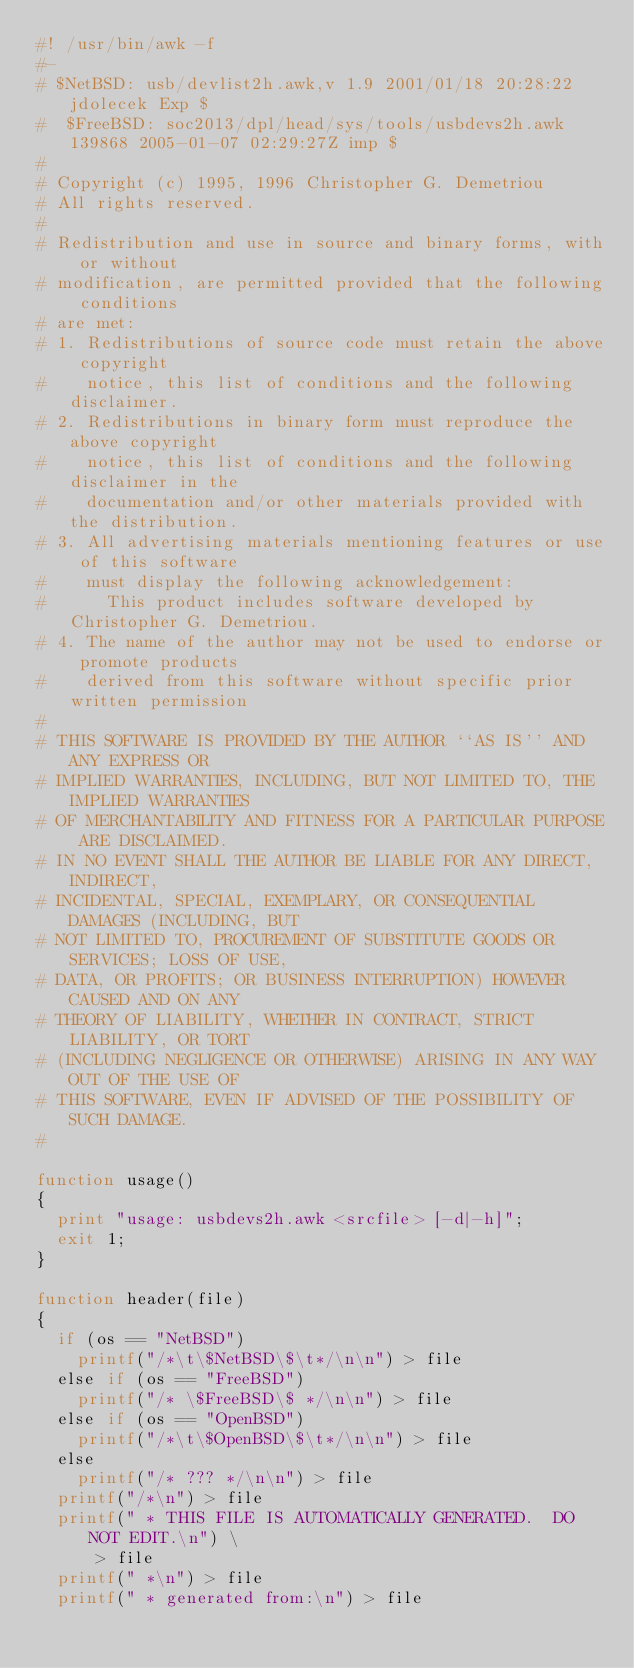Convert code to text. <code><loc_0><loc_0><loc_500><loc_500><_Awk_>#! /usr/bin/awk -f
#-
#	$NetBSD: usb/devlist2h.awk,v 1.9 2001/01/18 20:28:22 jdolecek Exp $
#  $FreeBSD: soc2013/dpl/head/sys/tools/usbdevs2h.awk 139868 2005-01-07 02:29:27Z imp $
#
# Copyright (c) 1995, 1996 Christopher G. Demetriou
# All rights reserved.
#
# Redistribution and use in source and binary forms, with or without
# modification, are permitted provided that the following conditions
# are met:
# 1. Redistributions of source code must retain the above copyright
#    notice, this list of conditions and the following disclaimer.
# 2. Redistributions in binary form must reproduce the above copyright
#    notice, this list of conditions and the following disclaimer in the
#    documentation and/or other materials provided with the distribution.
# 3. All advertising materials mentioning features or use of this software
#    must display the following acknowledgement:
#      This product includes software developed by Christopher G. Demetriou.
# 4. The name of the author may not be used to endorse or promote products
#    derived from this software without specific prior written permission
#
# THIS SOFTWARE IS PROVIDED BY THE AUTHOR ``AS IS'' AND ANY EXPRESS OR
# IMPLIED WARRANTIES, INCLUDING, BUT NOT LIMITED TO, THE IMPLIED WARRANTIES
# OF MERCHANTABILITY AND FITNESS FOR A PARTICULAR PURPOSE ARE DISCLAIMED.
# IN NO EVENT SHALL THE AUTHOR BE LIABLE FOR ANY DIRECT, INDIRECT,
# INCIDENTAL, SPECIAL, EXEMPLARY, OR CONSEQUENTIAL DAMAGES (INCLUDING, BUT
# NOT LIMITED TO, PROCUREMENT OF SUBSTITUTE GOODS OR SERVICES; LOSS OF USE,
# DATA, OR PROFITS; OR BUSINESS INTERRUPTION) HOWEVER CAUSED AND ON ANY
# THEORY OF LIABILITY, WHETHER IN CONTRACT, STRICT LIABILITY, OR TORT
# (INCLUDING NEGLIGENCE OR OTHERWISE) ARISING IN ANY WAY OUT OF THE USE OF
# THIS SOFTWARE, EVEN IF ADVISED OF THE POSSIBILITY OF SUCH DAMAGE.
#

function usage()
{
	print "usage: usbdevs2h.awk <srcfile> [-d|-h]";
	exit 1;
}

function header(file)
{
	if (os == "NetBSD")
		printf("/*\t\$NetBSD\$\t*/\n\n") > file
	else if (os == "FreeBSD")
		printf("/* \$FreeBSD\$ */\n\n") > file
	else if (os == "OpenBSD")
		printf("/*\t\$OpenBSD\$\t*/\n\n") > file
	else
		printf("/* ??? */\n\n") > file
	printf("/*\n") > file
	printf(" * THIS FILE IS AUTOMATICALLY GENERATED.  DO NOT EDIT.\n") \
	    > file
	printf(" *\n") > file
	printf(" * generated from:\n") > file</code> 